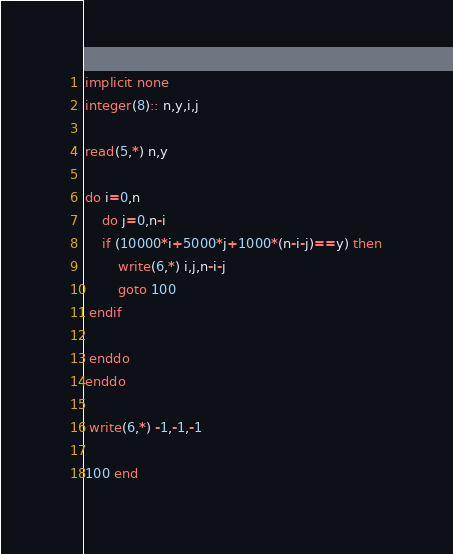<code> <loc_0><loc_0><loc_500><loc_500><_FORTRAN_>implicit none
integer(8):: n,y,i,j
 
read(5,*) n,y
 
do i=0,n
    do j=0,n-i
    if (10000*i+5000*j+1000*(n-i-j)==y) then
        write(6,*) i,j,n-i-j
        goto 100
 endif
 
 enddo
enddo
 
 write(6,*) -1,-1,-1
 
100 end</code> 